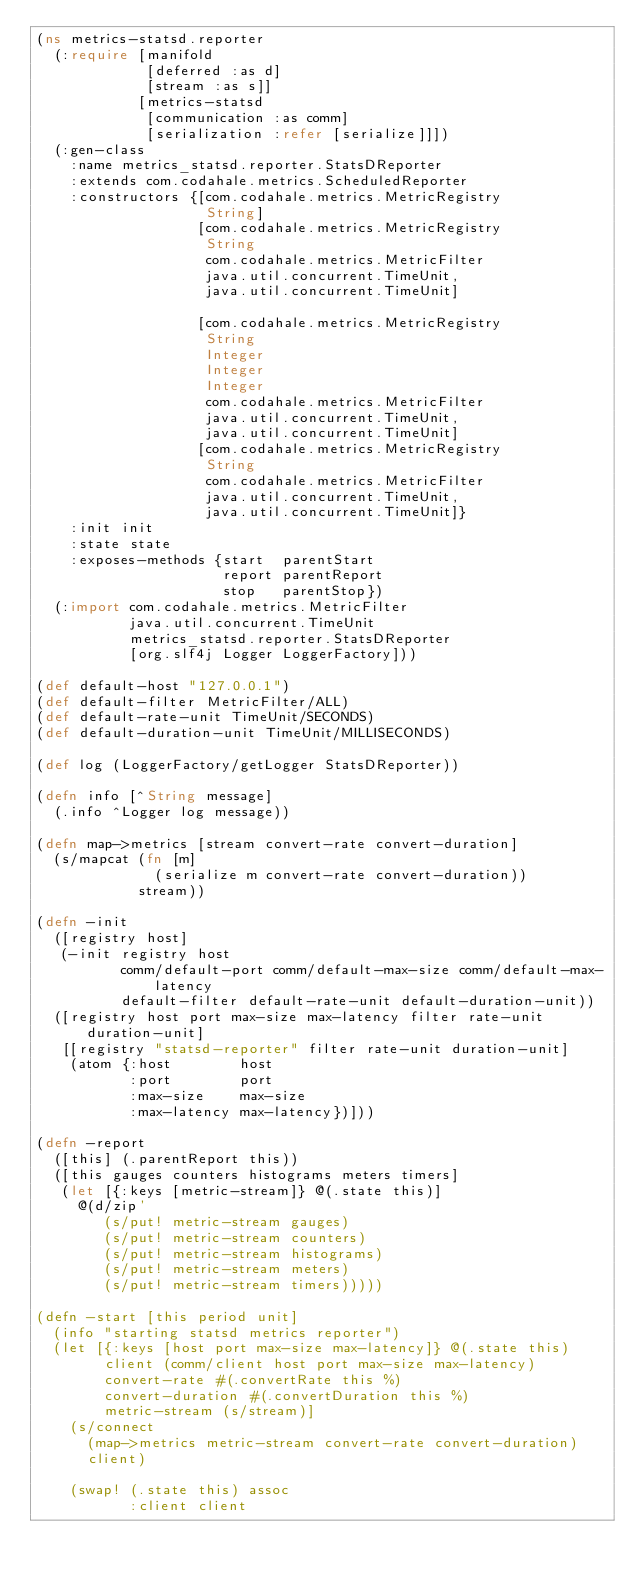Convert code to text. <code><loc_0><loc_0><loc_500><loc_500><_Clojure_>(ns metrics-statsd.reporter
  (:require [manifold
             [deferred :as d]
             [stream :as s]]
            [metrics-statsd
             [communication :as comm]
             [serialization :refer [serialize]]])
  (:gen-class
    :name metrics_statsd.reporter.StatsDReporter
    :extends com.codahale.metrics.ScheduledReporter
    :constructors {[com.codahale.metrics.MetricRegistry
                    String]
                   [com.codahale.metrics.MetricRegistry
                    String
                    com.codahale.metrics.MetricFilter
                    java.util.concurrent.TimeUnit,
                    java.util.concurrent.TimeUnit]

                   [com.codahale.metrics.MetricRegistry
                    String
                    Integer
                    Integer
                    Integer
                    com.codahale.metrics.MetricFilter
                    java.util.concurrent.TimeUnit,
                    java.util.concurrent.TimeUnit]
                   [com.codahale.metrics.MetricRegistry
                    String
                    com.codahale.metrics.MetricFilter
                    java.util.concurrent.TimeUnit,
                    java.util.concurrent.TimeUnit]}
    :init init
    :state state
    :exposes-methods {start  parentStart
                      report parentReport
                      stop   parentStop})
  (:import com.codahale.metrics.MetricFilter
           java.util.concurrent.TimeUnit
           metrics_statsd.reporter.StatsDReporter
           [org.slf4j Logger LoggerFactory]))

(def default-host "127.0.0.1")
(def default-filter MetricFilter/ALL)
(def default-rate-unit TimeUnit/SECONDS)
(def default-duration-unit TimeUnit/MILLISECONDS)

(def log (LoggerFactory/getLogger StatsDReporter))

(defn info [^String message]
  (.info ^Logger log message))

(defn map->metrics [stream convert-rate convert-duration]
  (s/mapcat (fn [m]
              (serialize m convert-rate convert-duration))
            stream))

(defn -init
  ([registry host]
   (-init registry host
          comm/default-port comm/default-max-size comm/default-max-latency
          default-filter default-rate-unit default-duration-unit))
  ([registry host port max-size max-latency filter rate-unit duration-unit]
   [[registry "statsd-reporter" filter rate-unit duration-unit]
    (atom {:host        host
           :port        port
           :max-size    max-size
           :max-latency max-latency})]))

(defn -report
  ([this] (.parentReport this))
  ([this gauges counters histograms meters timers]
   (let [{:keys [metric-stream]} @(.state this)]
     @(d/zip'
        (s/put! metric-stream gauges)
        (s/put! metric-stream counters)
        (s/put! metric-stream histograms)
        (s/put! metric-stream meters)
        (s/put! metric-stream timers)))))

(defn -start [this period unit]
  (info "starting statsd metrics reporter")
  (let [{:keys [host port max-size max-latency]} @(.state this)
        client (comm/client host port max-size max-latency)
        convert-rate #(.convertRate this %)
        convert-duration #(.convertDuration this %)
        metric-stream (s/stream)]
    (s/connect
      (map->metrics metric-stream convert-rate convert-duration)
      client)

    (swap! (.state this) assoc
           :client client</code> 